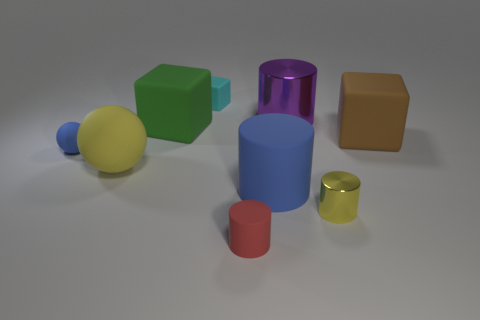Subtract all green rubber cubes. How many cubes are left? 2 Subtract all blue cylinders. How many cylinders are left? 3 Add 1 cyan rubber balls. How many objects exist? 10 Subtract all blue cubes. Subtract all gray cylinders. How many cubes are left? 3 Subtract all blocks. How many objects are left? 6 Subtract all red rubber cylinders. Subtract all metallic cylinders. How many objects are left? 6 Add 2 big green blocks. How many big green blocks are left? 3 Add 6 tiny green metallic cylinders. How many tiny green metallic cylinders exist? 6 Subtract 1 yellow cylinders. How many objects are left? 8 